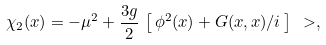Convert formula to latex. <formula><loc_0><loc_0><loc_500><loc_500>\chi _ { 2 } ( x ) = - \mu ^ { 2 } + \frac { 3 g } { 2 } \, \left [ \, \phi ^ { 2 } ( x ) + G ( x , x ) / i \, \right ] \ > ,</formula> 